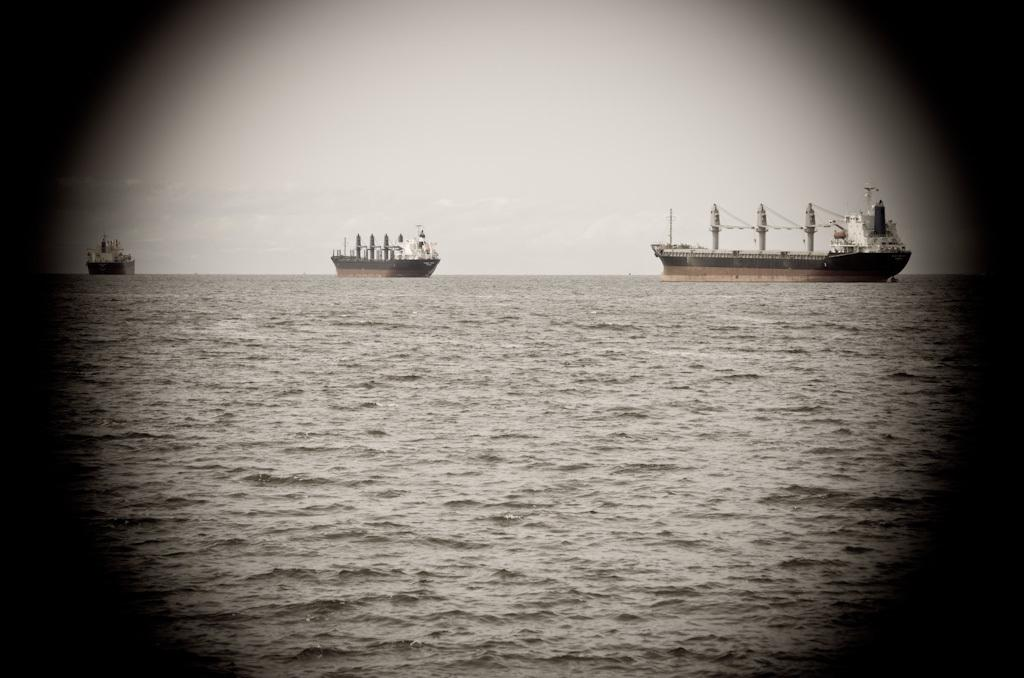What is visible in the image? There is water visible in the image, along with huge ships on the surface of the water. What can be seen in the background of the image? The sky is visible in the background of the image. What type of rhythm can be heard coming from the ships in the image? There is no sound or rhythm present in the image, as it is a still picture of ships on water. Can you see a hammer being used on any of the ships in the image? There is no hammer or any indication of construction or repair work being done on the ships in the image. 